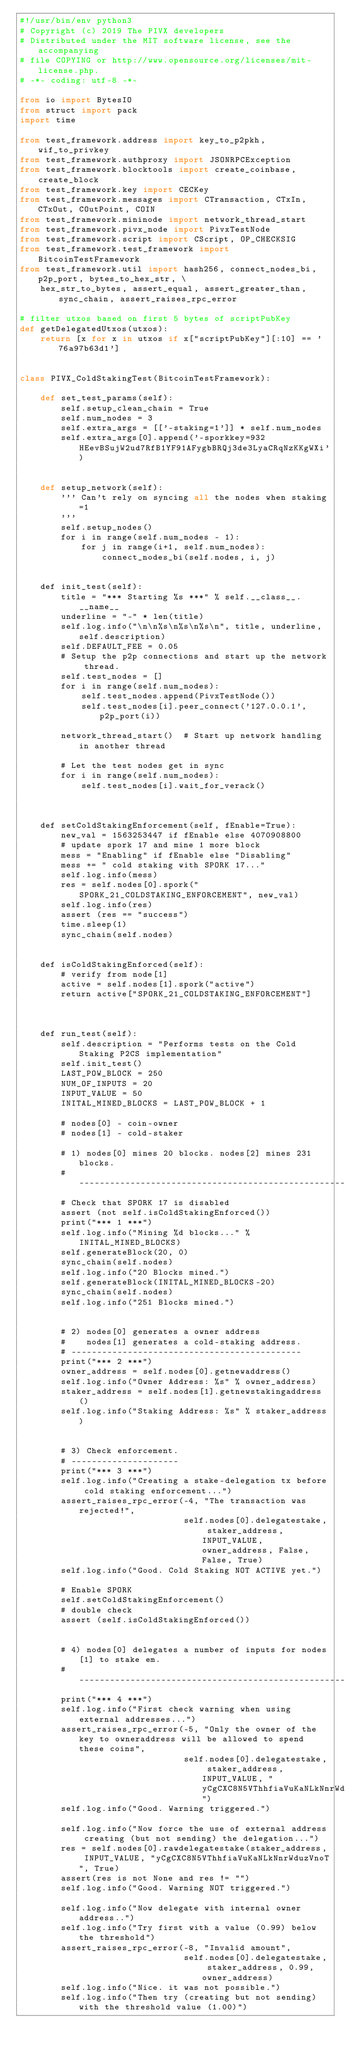<code> <loc_0><loc_0><loc_500><loc_500><_Python_>#!/usr/bin/env python3
# Copyright (c) 2019 The PIVX developers
# Distributed under the MIT software license, see the accompanying
# file COPYING or http://www.opensource.org/licenses/mit-license.php.
# -*- coding: utf-8 -*-

from io import BytesIO
from struct import pack
import time

from test_framework.address import key_to_p2pkh, wif_to_privkey
from test_framework.authproxy import JSONRPCException
from test_framework.blocktools import create_coinbase, create_block
from test_framework.key import CECKey
from test_framework.messages import CTransaction, CTxIn, CTxOut, COutPoint, COIN
from test_framework.mininode import network_thread_start
from test_framework.pivx_node import PivxTestNode
from test_framework.script import CScript, OP_CHECKSIG
from test_framework.test_framework import BitcoinTestFramework
from test_framework.util import hash256, connect_nodes_bi, p2p_port, bytes_to_hex_str, \
    hex_str_to_bytes, assert_equal, assert_greater_than, sync_chain, assert_raises_rpc_error

# filter utxos based on first 5 bytes of scriptPubKey
def getDelegatedUtxos(utxos):
    return [x for x in utxos if x["scriptPubKey"][:10] == '76a97b63d1']


class PIVX_ColdStakingTest(BitcoinTestFramework):

    def set_test_params(self):
        self.setup_clean_chain = True
        self.num_nodes = 3
        self.extra_args = [['-staking=1']] * self.num_nodes
        self.extra_args[0].append('-sporkkey=932HEevBSujW2ud7RfB1YF91AFygbBRQj3de3LyaCRqNzKKgWXi')


    def setup_network(self):
        ''' Can't rely on syncing all the nodes when staking=1
        '''
        self.setup_nodes()
        for i in range(self.num_nodes - 1):
            for j in range(i+1, self.num_nodes):
                connect_nodes_bi(self.nodes, i, j)


    def init_test(self):
        title = "*** Starting %s ***" % self.__class__.__name__
        underline = "-" * len(title)
        self.log.info("\n\n%s\n%s\n%s\n", title, underline, self.description)
        self.DEFAULT_FEE = 0.05
        # Setup the p2p connections and start up the network thread.
        self.test_nodes = []
        for i in range(self.num_nodes):
            self.test_nodes.append(PivxTestNode())
            self.test_nodes[i].peer_connect('127.0.0.1', p2p_port(i))

        network_thread_start()  # Start up network handling in another thread

        # Let the test nodes get in sync
        for i in range(self.num_nodes):
            self.test_nodes[i].wait_for_verack()



    def setColdStakingEnforcement(self, fEnable=True):
        new_val = 1563253447 if fEnable else 4070908800
        # update spork 17 and mine 1 more block
        mess = "Enabling" if fEnable else "Disabling"
        mess += " cold staking with SPORK 17..."
        self.log.info(mess)
        res = self.nodes[0].spork("SPORK_21_COLDSTAKING_ENFORCEMENT", new_val)
        self.log.info(res)
        assert (res == "success")
        time.sleep(1)
        sync_chain(self.nodes)


    def isColdStakingEnforced(self):
        # verify from node[1]
        active = self.nodes[1].spork("active")
        return active["SPORK_21_COLDSTAKING_ENFORCEMENT"]



    def run_test(self):
        self.description = "Performs tests on the Cold Staking P2CS implementation"
        self.init_test()
        LAST_POW_BLOCK = 250
        NUM_OF_INPUTS = 20
        INPUT_VALUE = 50
        INITAL_MINED_BLOCKS = LAST_POW_BLOCK + 1

        # nodes[0] - coin-owner
        # nodes[1] - cold-staker

        # 1) nodes[0] mines 20 blocks. nodes[2] mines 231 blocks.
        # -----------------------------------------------------------
        # Check that SPORK 17 is disabled
        assert (not self.isColdStakingEnforced())
        print("*** 1 ***")
        self.log.info("Mining %d blocks..." % INITAL_MINED_BLOCKS)
        self.generateBlock(20, 0)
        sync_chain(self.nodes)
        self.log.info("20 Blocks mined.")
        self.generateBlock(INITAL_MINED_BLOCKS-20)
        sync_chain(self.nodes)
        self.log.info("251 Blocks mined.")


        # 2) nodes[0] generates a owner address
        #    nodes[1] generates a cold-staking address.
        # ---------------------------------------------
        print("*** 2 ***")
        owner_address = self.nodes[0].getnewaddress()
        self.log.info("Owner Address: %s" % owner_address)
        staker_address = self.nodes[1].getnewstakingaddress()
        self.log.info("Staking Address: %s" % staker_address)


        # 3) Check enforcement.
        # ---------------------
        print("*** 3 ***")
        self.log.info("Creating a stake-delegation tx before cold staking enforcement...")
        assert_raises_rpc_error(-4, "The transaction was rejected!",
                                self.nodes[0].delegatestake, staker_address, INPUT_VALUE, owner_address, False, False, True)
        self.log.info("Good. Cold Staking NOT ACTIVE yet.")

        # Enable SPORK
        self.setColdStakingEnforcement()
        # double check
        assert (self.isColdStakingEnforced())


        # 4) nodes[0] delegates a number of inputs for nodes[1] to stake em.
        # ------------------------------------------------------------------
        print("*** 4 ***")
        self.log.info("First check warning when using external addresses...")
        assert_raises_rpc_error(-5, "Only the owner of the key to owneraddress will be allowed to spend these coins",
                                self.nodes[0].delegatestake, staker_address, INPUT_VALUE, "yCgCXC8N5VThhfiaVuKaNLkNnrWduzVnoT")
        self.log.info("Good. Warning triggered.")

        self.log.info("Now force the use of external address creating (but not sending) the delegation...")
        res = self.nodes[0].rawdelegatestake(staker_address, INPUT_VALUE, "yCgCXC8N5VThhfiaVuKaNLkNnrWduzVnoT", True)
        assert(res is not None and res != "")
        self.log.info("Good. Warning NOT triggered.")

        self.log.info("Now delegate with internal owner address..")
        self.log.info("Try first with a value (0.99) below the threshold")
        assert_raises_rpc_error(-8, "Invalid amount",
                                self.nodes[0].delegatestake, staker_address, 0.99, owner_address)
        self.log.info("Nice. it was not possible.")
        self.log.info("Then try (creating but not sending) with the threshold value (1.00)")</code> 